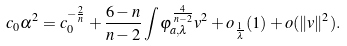Convert formula to latex. <formula><loc_0><loc_0><loc_500><loc_500>c _ { 0 } \alpha ^ { 2 } = c _ { 0 } ^ { - \frac { 2 } { n } } + \frac { 6 - n } { n - 2 } \int \varphi _ { a , \lambda } ^ { \frac { 4 } { n - 2 } } v ^ { 2 } + o _ { \frac { 1 } { \lambda } } ( 1 ) + o ( \| v \| ^ { 2 } ) .</formula> 